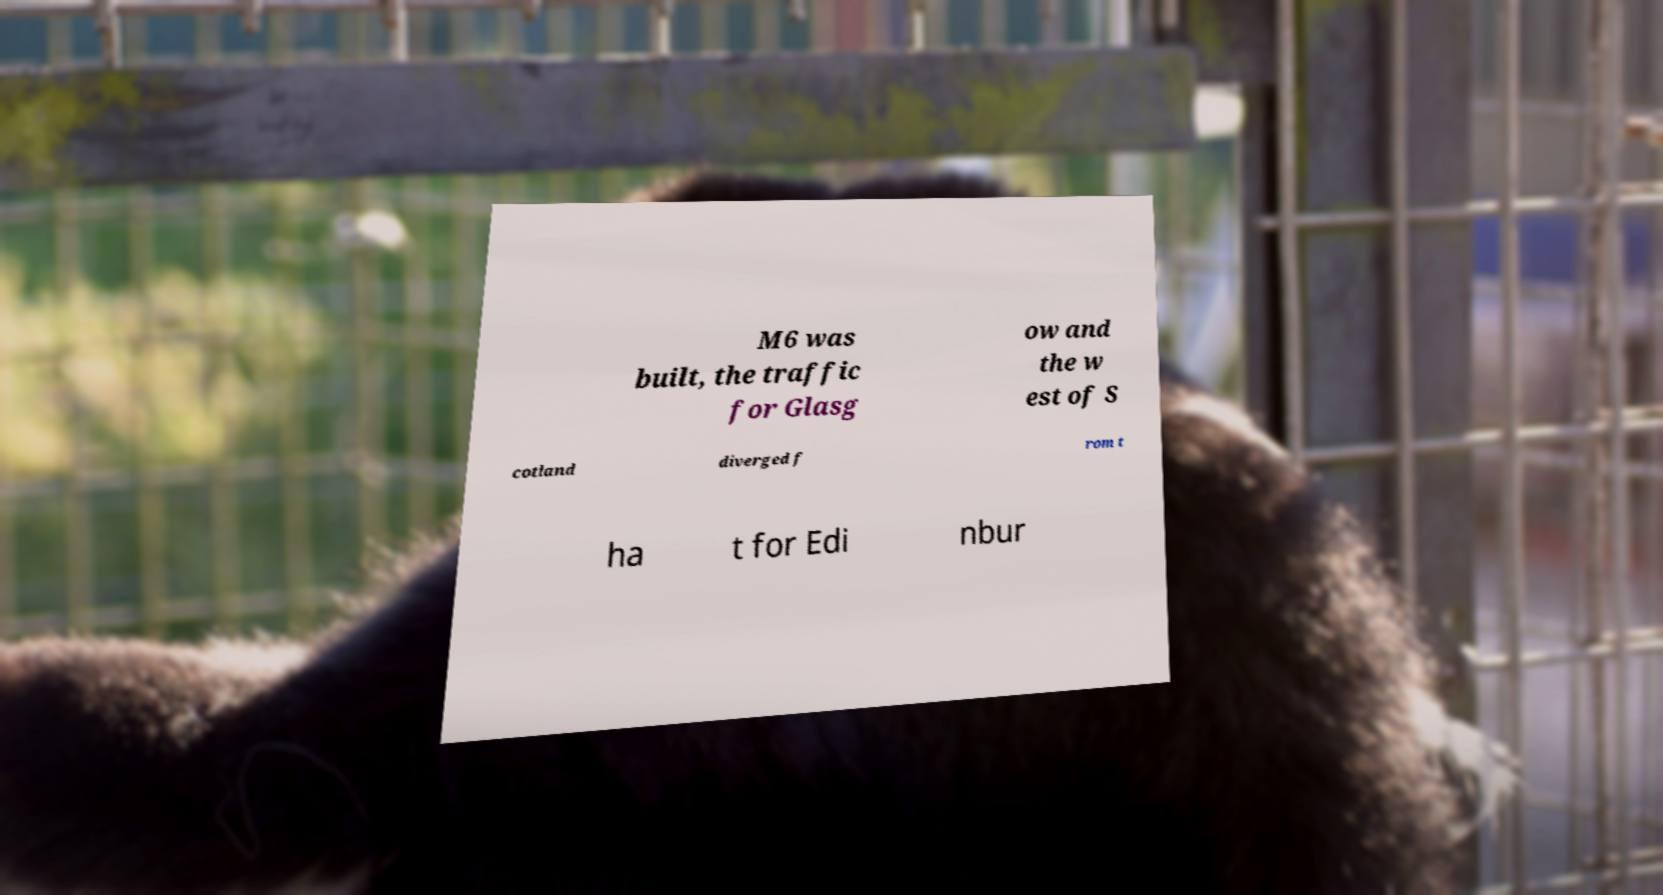Can you accurately transcribe the text from the provided image for me? M6 was built, the traffic for Glasg ow and the w est of S cotland diverged f rom t ha t for Edi nbur 